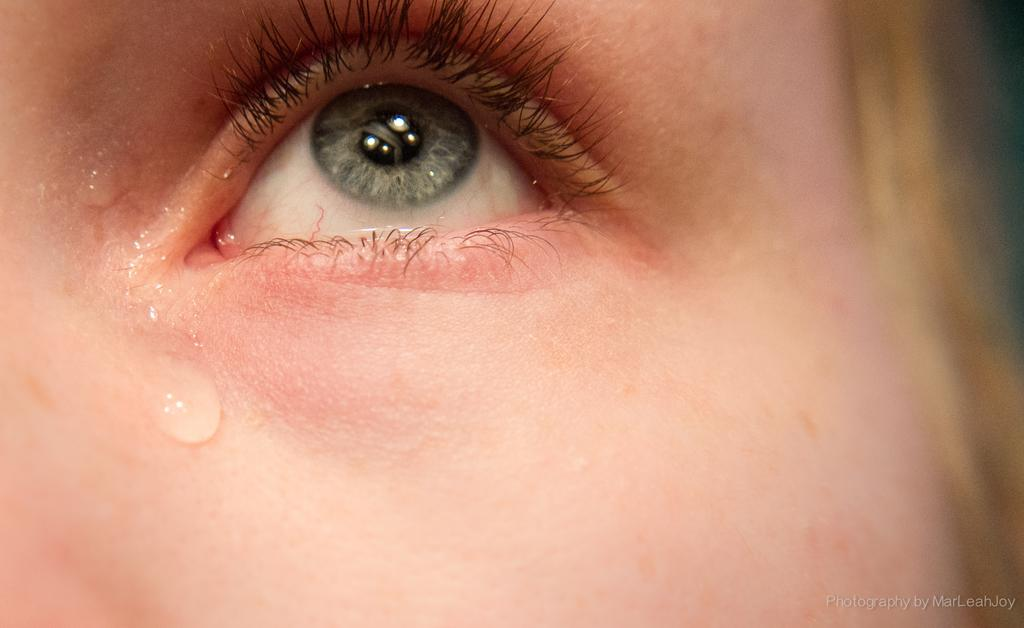What is the main subject of the image? The main subject of the image is the eye of a person. Can you describe any other features visible in the image? Yes, there is water visible on the face in the image. How many stars can be seen in the image? There are no stars present in the image. What type of trees are visible in the image? There are no trees visible in the image. 